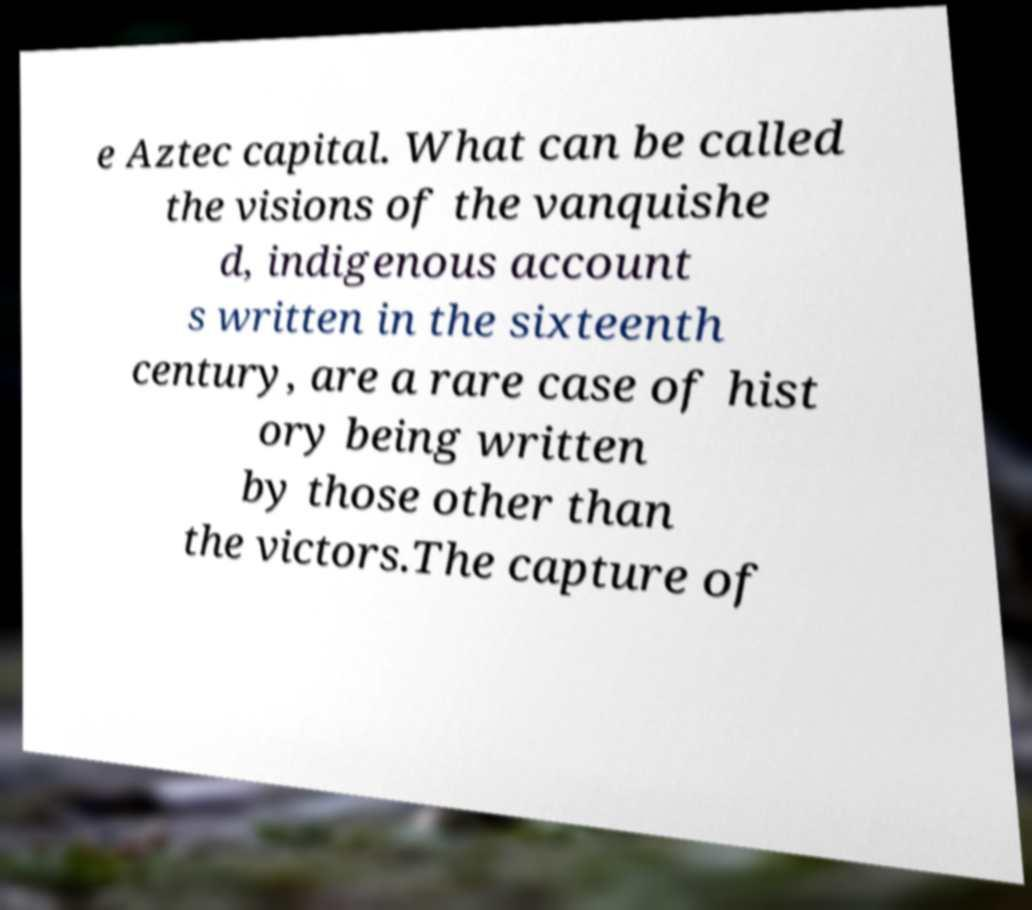Could you assist in decoding the text presented in this image and type it out clearly? e Aztec capital. What can be called the visions of the vanquishe d, indigenous account s written in the sixteenth century, are a rare case of hist ory being written by those other than the victors.The capture of 